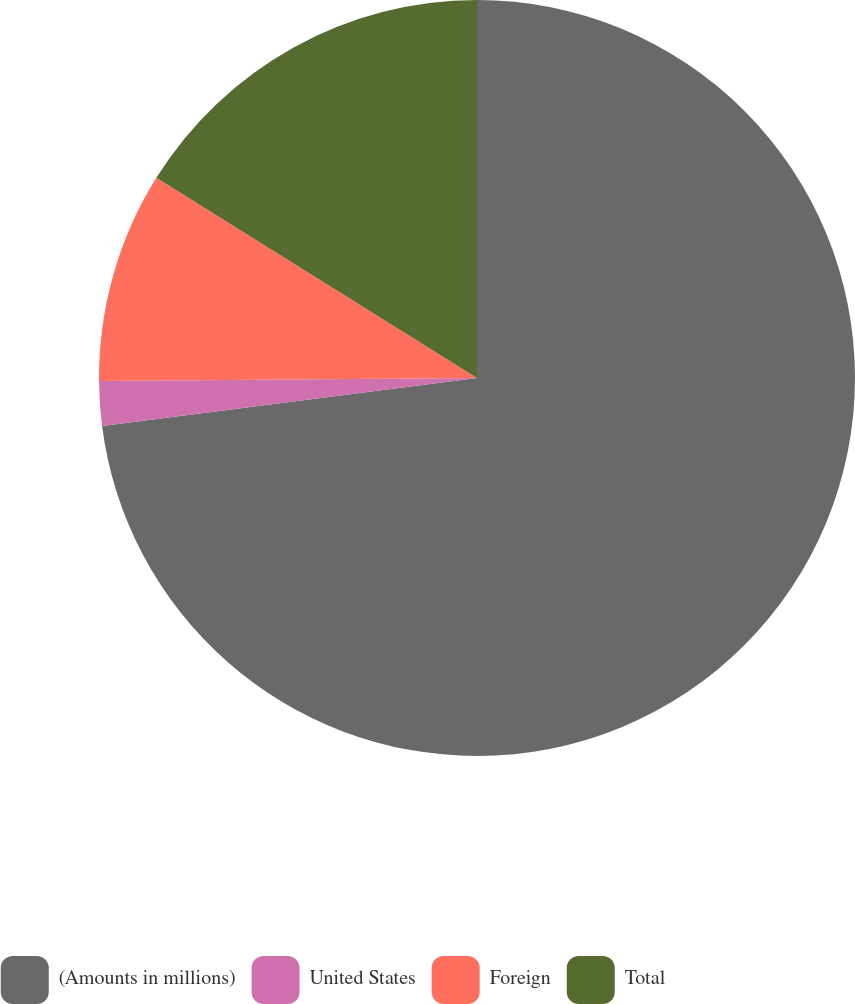<chart> <loc_0><loc_0><loc_500><loc_500><pie_chart><fcel>(Amounts in millions)<fcel>United States<fcel>Foreign<fcel>Total<nl><fcel>72.97%<fcel>1.9%<fcel>9.01%<fcel>16.12%<nl></chart> 